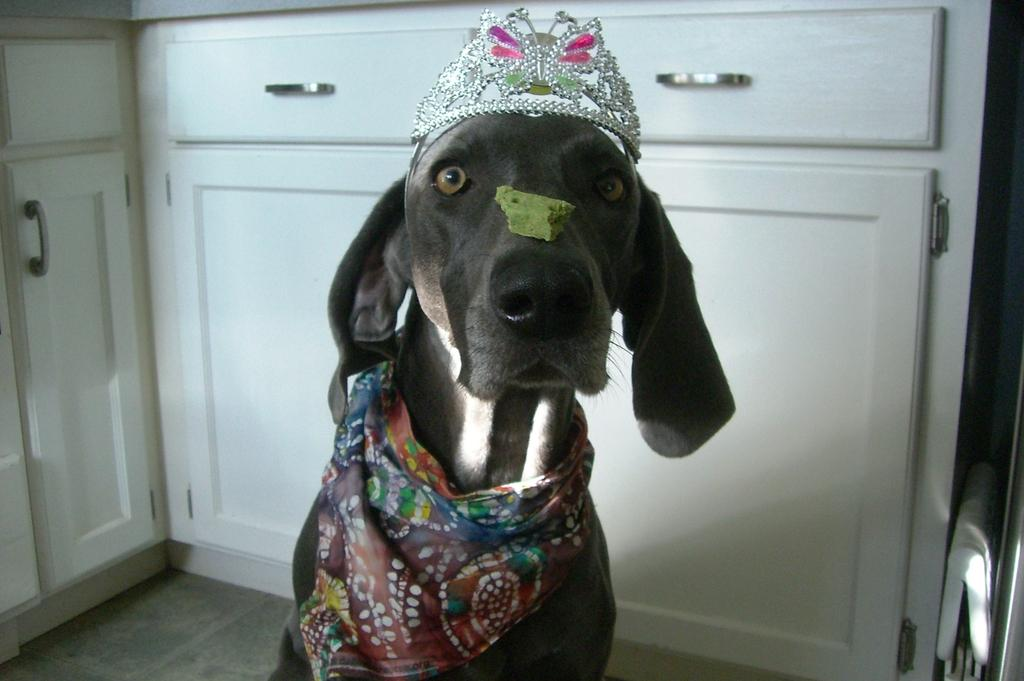What type of animal is in the image? There is a dog in the image. What is the dog wearing? The dog is wearing a crown. What is on the dog's nose? There is something on the dog's nose. What can be seen in the background of the image? There are cupboards visible in the background of the image. What type of jelly is the writer using to create the image? There is no mention of a writer or jelly in the image or the provided facts. 